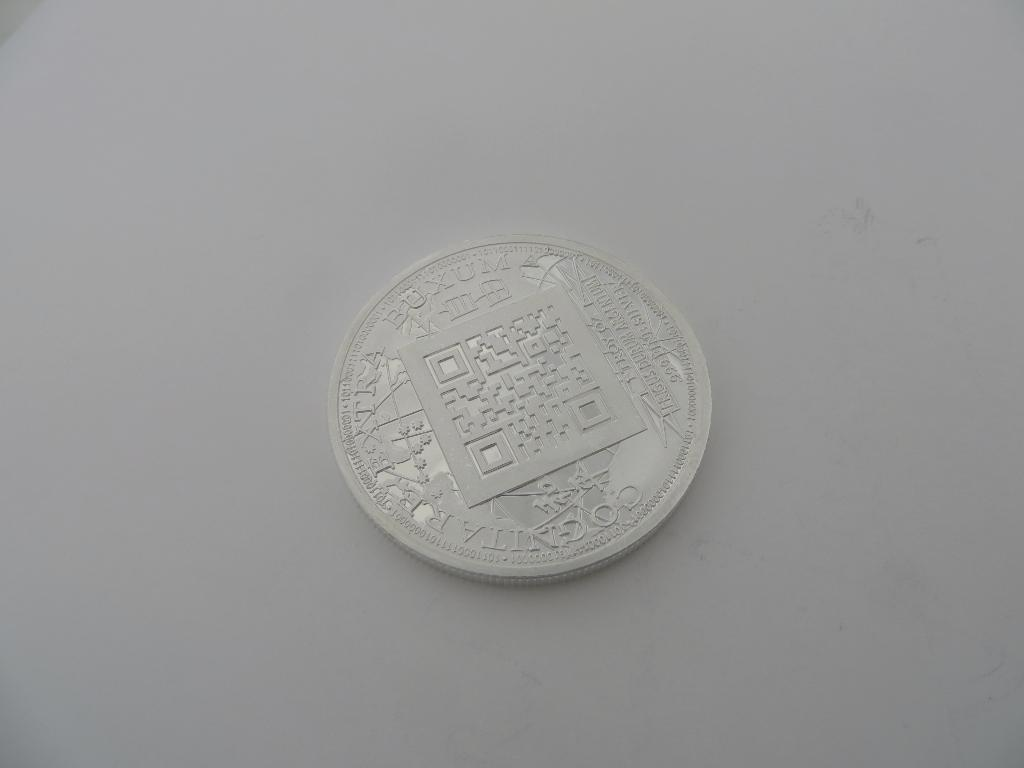<image>
Relay a brief, clear account of the picture shown. a silver coin that say the word buxum on the top of it 